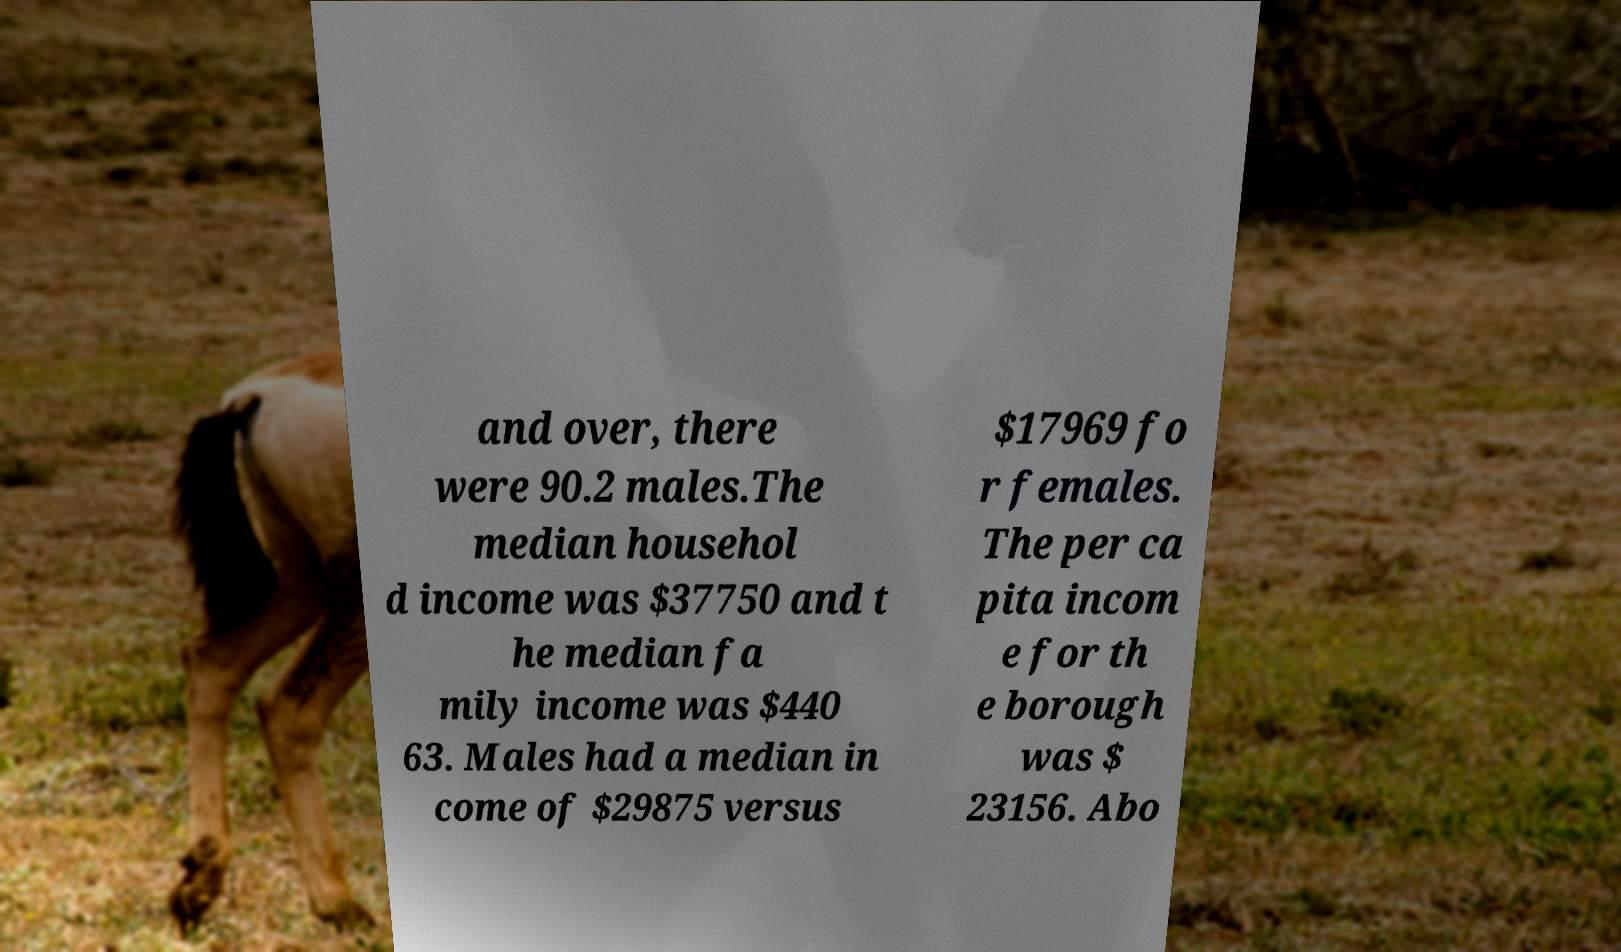Please read and relay the text visible in this image. What does it say? and over, there were 90.2 males.The median househol d income was $37750 and t he median fa mily income was $440 63. Males had a median in come of $29875 versus $17969 fo r females. The per ca pita incom e for th e borough was $ 23156. Abo 